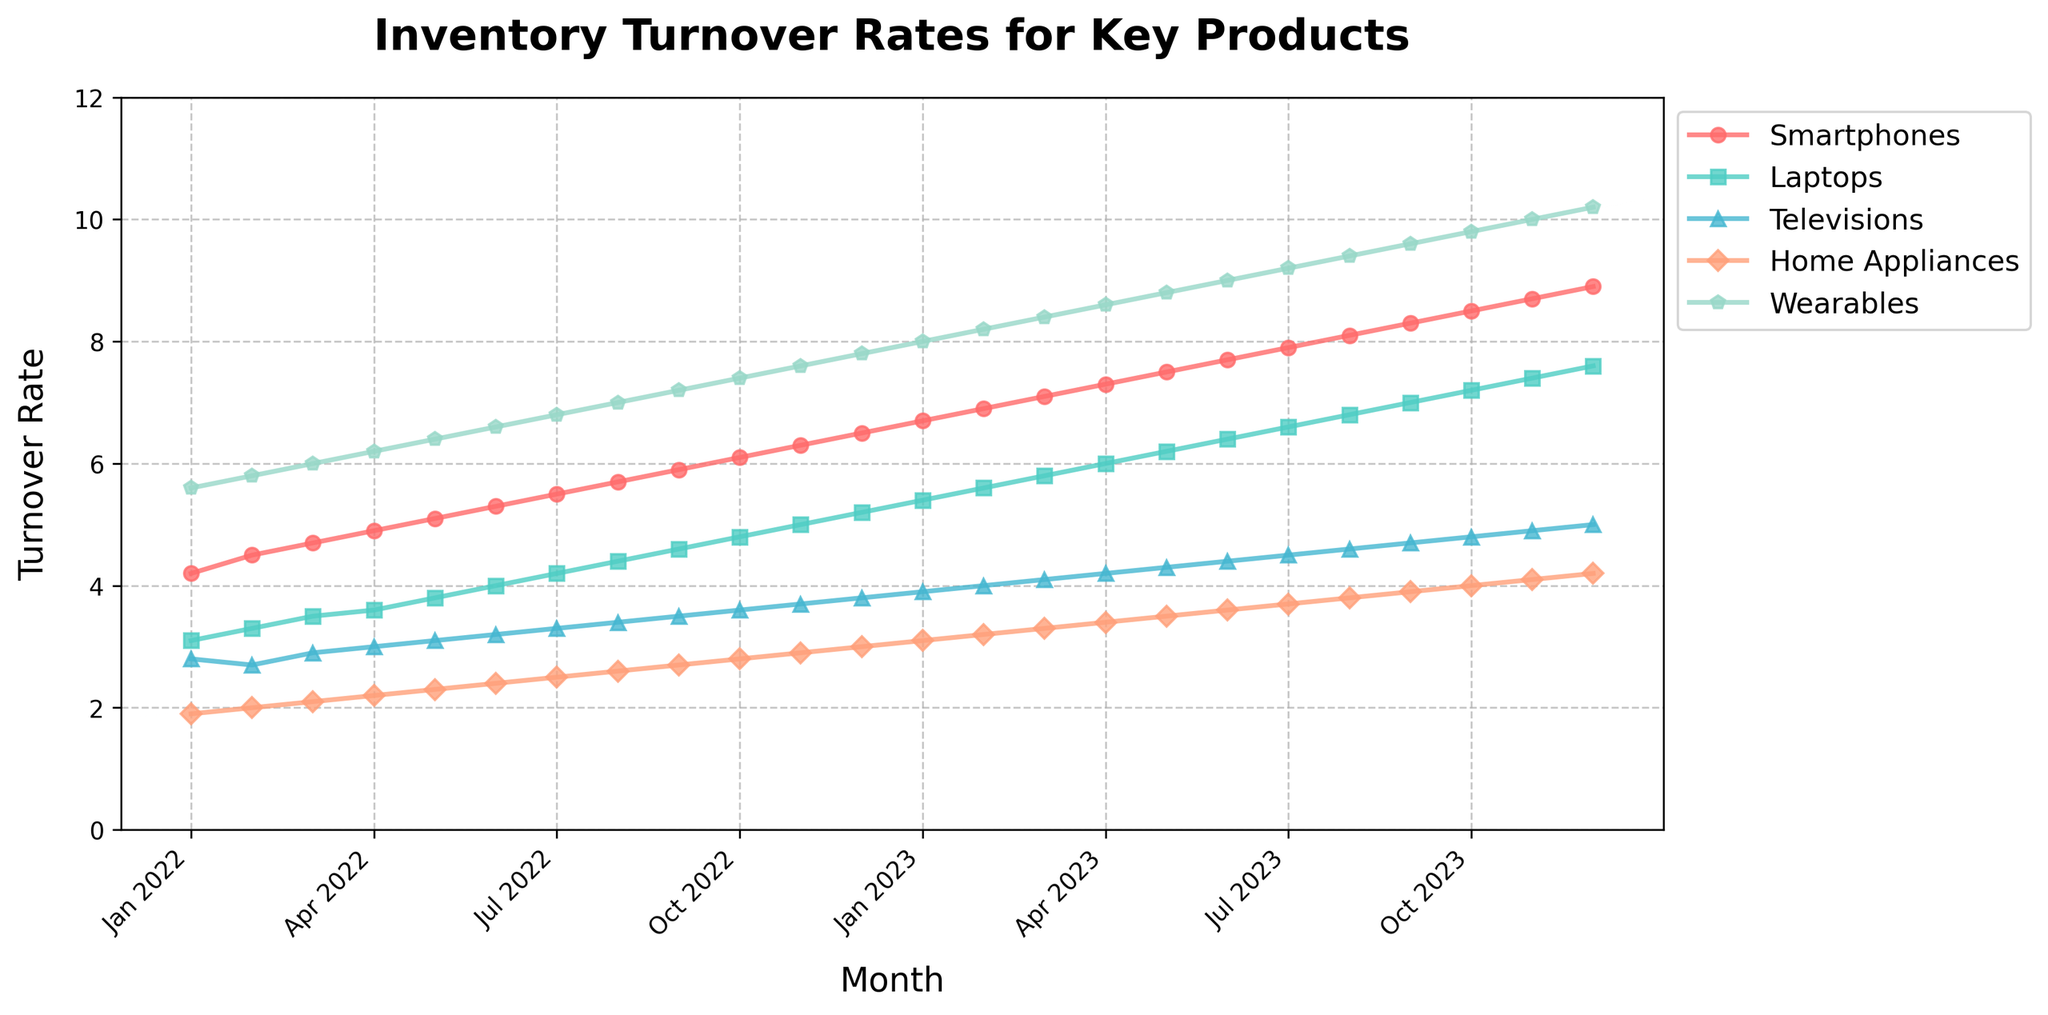Which product has the highest turnover rate in Jan 2022? The product with the highest turnover rate has the highest point on the graph for Jan 2022, which is Wearables at 5.6.
Answer: Wearables What is the total inventory turnover rate for Smartphones and Laptops in Jan 2023? The inventory turnover rate for Smartphones in Jan 2023 is 6.7, and for Laptops, it is 5.4. Summing these rates gives 6.7 + 5.4 = 12.1.
Answer: 12.1 Which product shows the most consistent increase in turnover rate over the 24 months? By observing the slopes of the lines, Smartphones have the most consistent and steadily rising turnover rate with no drops.
Answer: Smartphones Between May 2022 and May 2023, which product saw the greatest increase in turnover rate? By how much did it increase? SmartPhones' turnover rate increased from 5.1 in May 2022 to 7.5 in May 2023. The increase is 7.5 - 5.1 = 2.4.
Answer: Smartphones, 2.4 How does the turnover rate of Home Appliances in Dec 2022 compare to the turnover rate of Televisions in Dec 2023? The turnover rate for Home Appliances in Dec 2022 is 3.0, and for Televisions in Dec 2023 is 5.0. Comparing these values, 5.0 is greater than 3.0.
Answer: 5.0 > 3.0 What is the average turnover rate for Wearables across the entire period? Add up all monthly turnover rates for Wearables and divide by 24. The sum is 204 and the average is 204 / 24 = 8.5.
Answer: 8.5 Which product had the lowest turnover rate in Oct 2022, and what was the value? The lowest turnover rate corresponds to the lowest point on the graph for Oct 2022, which is Home Appliances at 2.8.
Answer: Home Appliances, 2.8 Is there any product whose turnover rate never decreased over the 24 months? Observing the lines' trend, Smartphones' turnover rate consistently increased without any decline.
Answer: Smartphones How did the turnover rate change for Televisions from March 2022 to March 2023? The turnover rate for Televisions in March 2022 was 2.9, and in March 2023, it was 4.1. The change is 4.1 - 2.9 = 1.2.
Answer: Increased by 1.2 Which two products have the closest turnover rates in Sep 2023? How close are they? Laptops and Televisions have turnover rates of 7.0 and 4.7, respectively, in Sep 2023. The difference is 7.0 - 4.7 = 2.3.
Answer: Laptops and Televisions, 2.3 